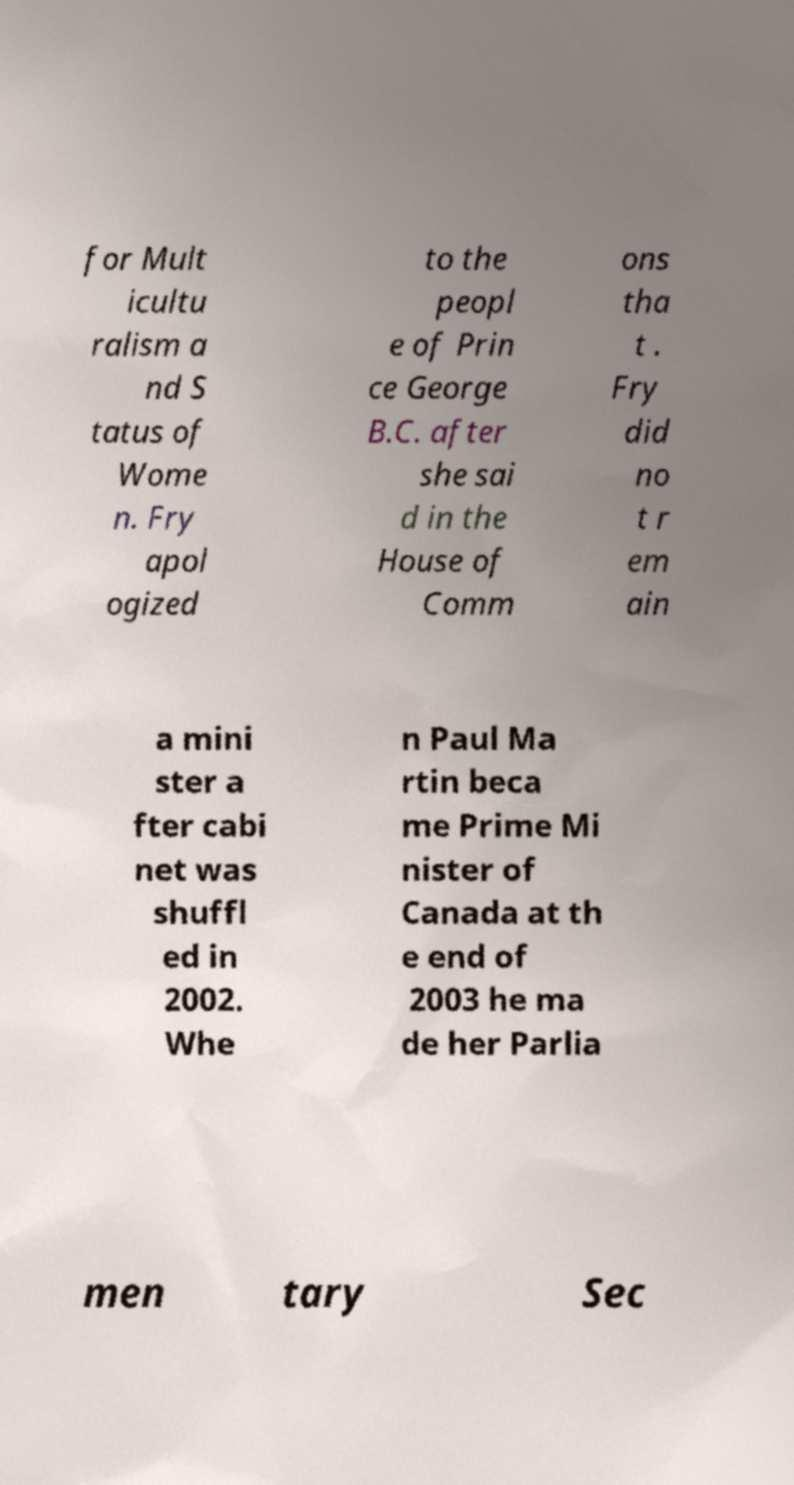Could you extract and type out the text from this image? for Mult icultu ralism a nd S tatus of Wome n. Fry apol ogized to the peopl e of Prin ce George B.C. after she sai d in the House of Comm ons tha t . Fry did no t r em ain a mini ster a fter cabi net was shuffl ed in 2002. Whe n Paul Ma rtin beca me Prime Mi nister of Canada at th e end of 2003 he ma de her Parlia men tary Sec 